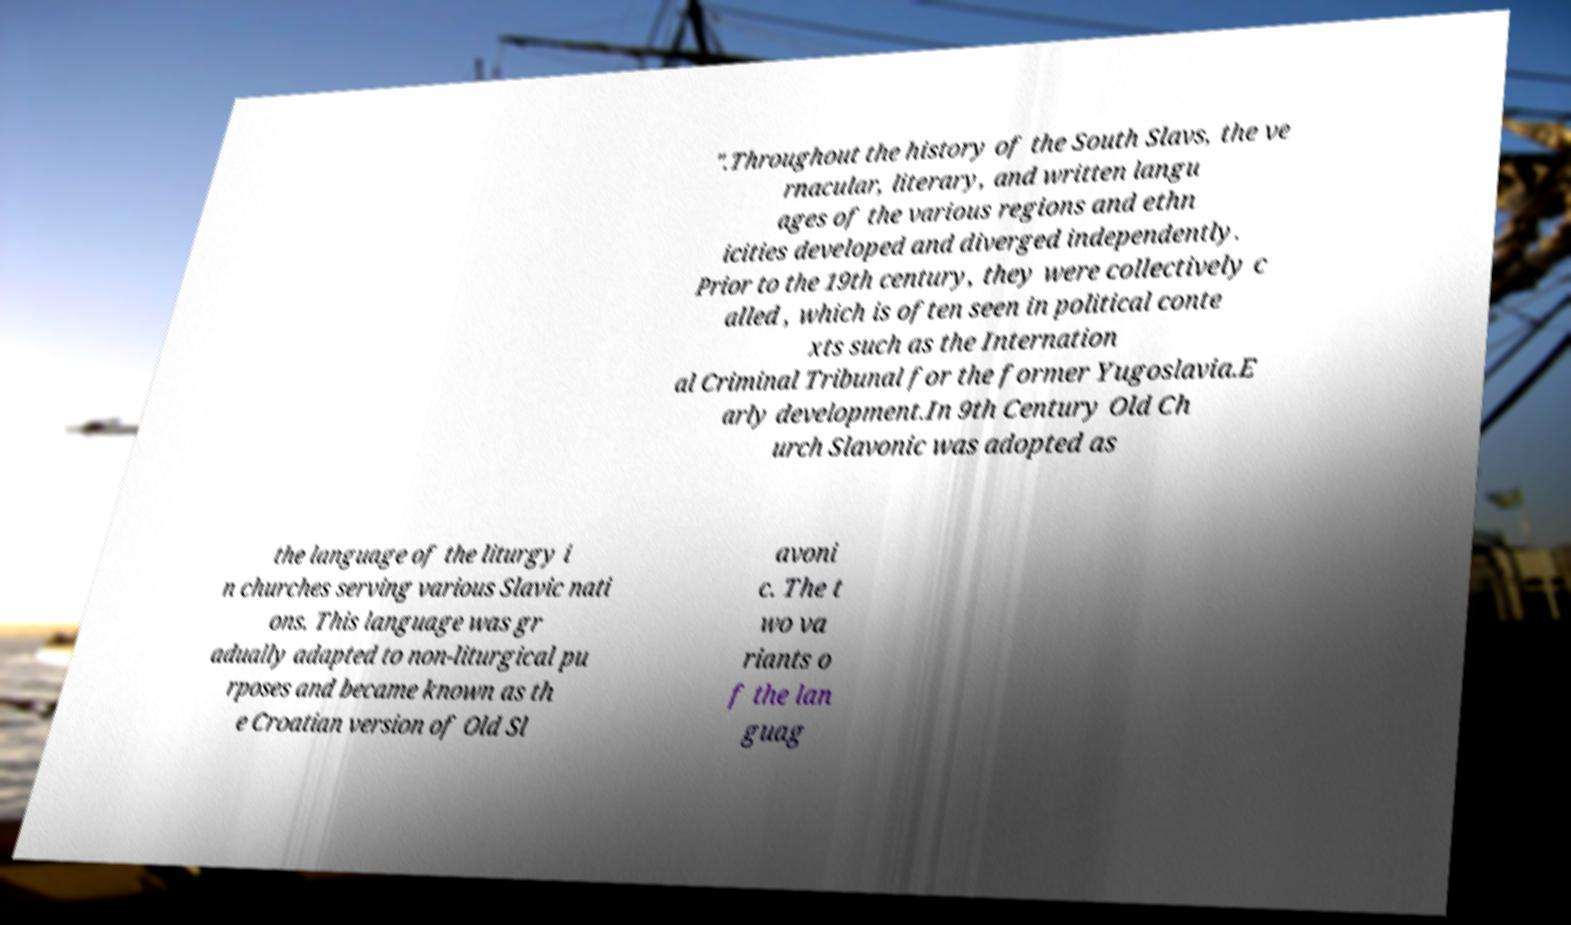What messages or text are displayed in this image? I need them in a readable, typed format. ".Throughout the history of the South Slavs, the ve rnacular, literary, and written langu ages of the various regions and ethn icities developed and diverged independently. Prior to the 19th century, they were collectively c alled , which is often seen in political conte xts such as the Internation al Criminal Tribunal for the former Yugoslavia.E arly development.In 9th Century Old Ch urch Slavonic was adopted as the language of the liturgy i n churches serving various Slavic nati ons. This language was gr adually adapted to non-liturgical pu rposes and became known as th e Croatian version of Old Sl avoni c. The t wo va riants o f the lan guag 